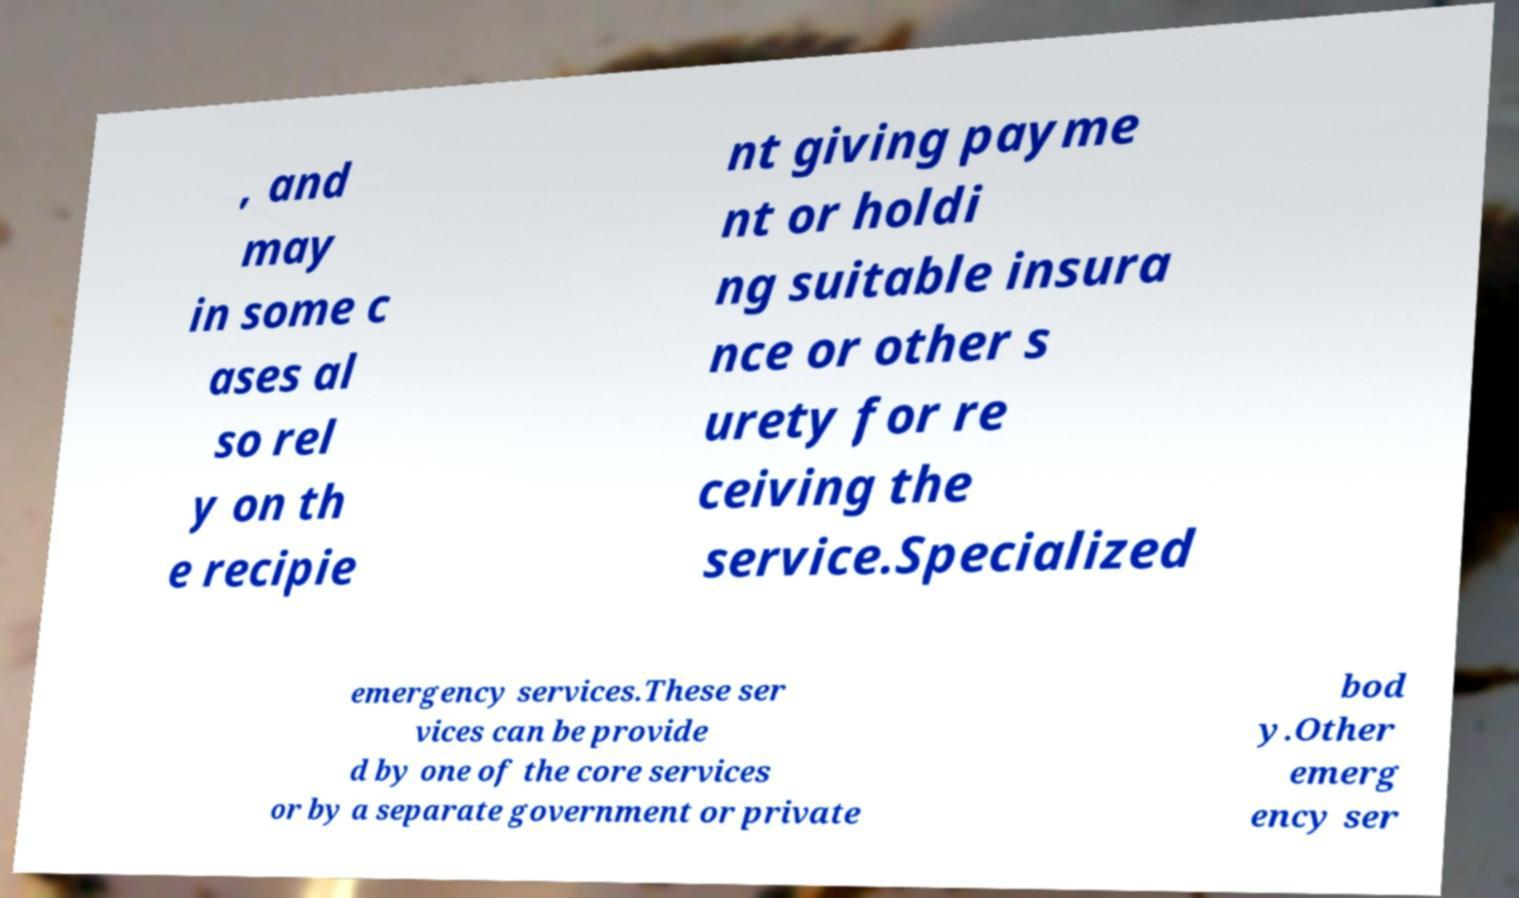For documentation purposes, I need the text within this image transcribed. Could you provide that? , and may in some c ases al so rel y on th e recipie nt giving payme nt or holdi ng suitable insura nce or other s urety for re ceiving the service.Specialized emergency services.These ser vices can be provide d by one of the core services or by a separate government or private bod y.Other emerg ency ser 